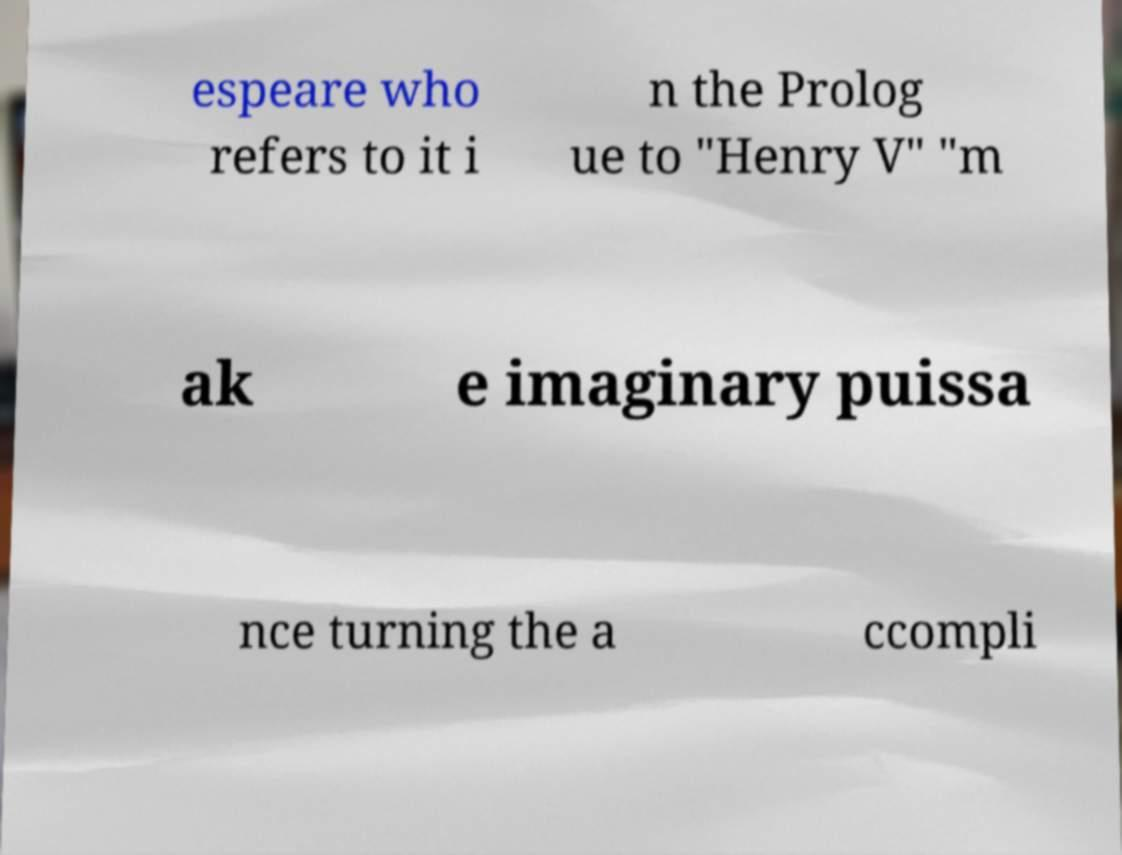Please identify and transcribe the text found in this image. espeare who refers to it i n the Prolog ue to "Henry V" "m ak e imaginary puissa nce turning the a ccompli 